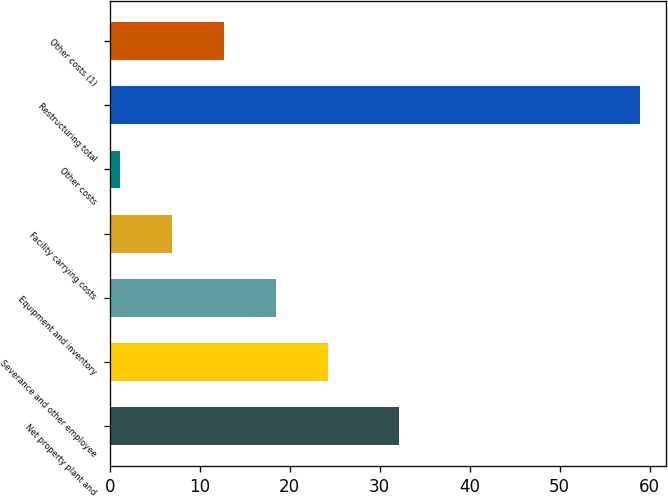<chart> <loc_0><loc_0><loc_500><loc_500><bar_chart><fcel>Net property plant and<fcel>Severance and other employee<fcel>Equipment and inventory<fcel>Facility carrying costs<fcel>Other costs<fcel>Restructuring total<fcel>Other costs (1)<nl><fcel>32.1<fcel>24.28<fcel>18.51<fcel>6.97<fcel>1.2<fcel>58.9<fcel>12.74<nl></chart> 